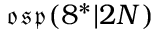Convert formula to latex. <formula><loc_0><loc_0><loc_500><loc_500>{ \mathfrak { o s p } } ( 8 ^ { * } | 2 N )</formula> 